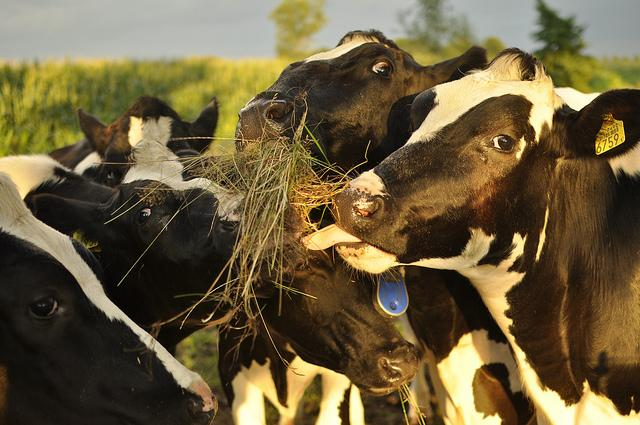What are the animals eating?

Choices:
A) grass
B) dirt
C) hay
D) food grass 